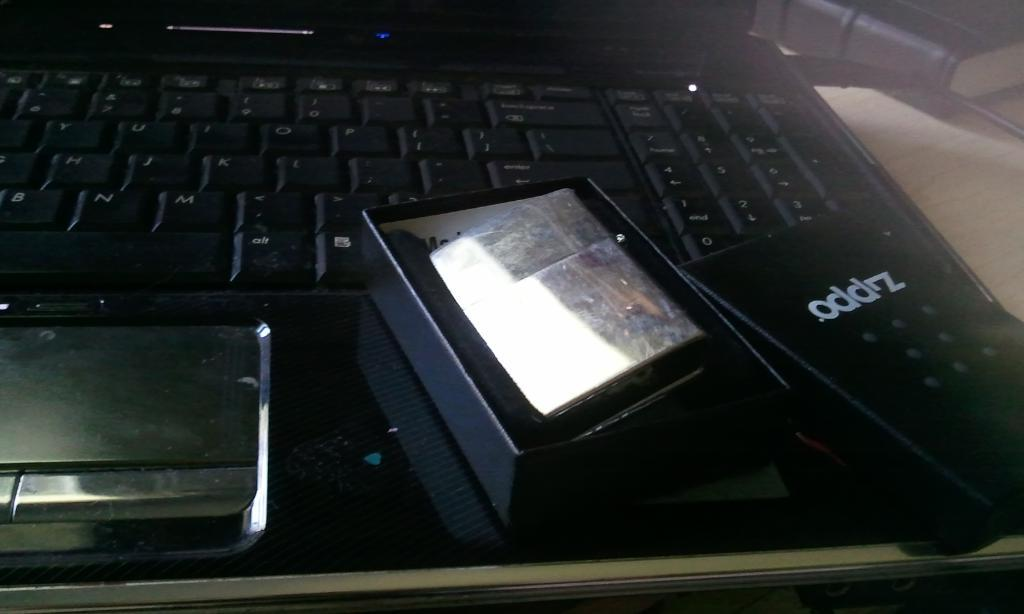<image>
Relay a brief, clear account of the picture shown. Laptop with a box that has the word "oddz" on it. 